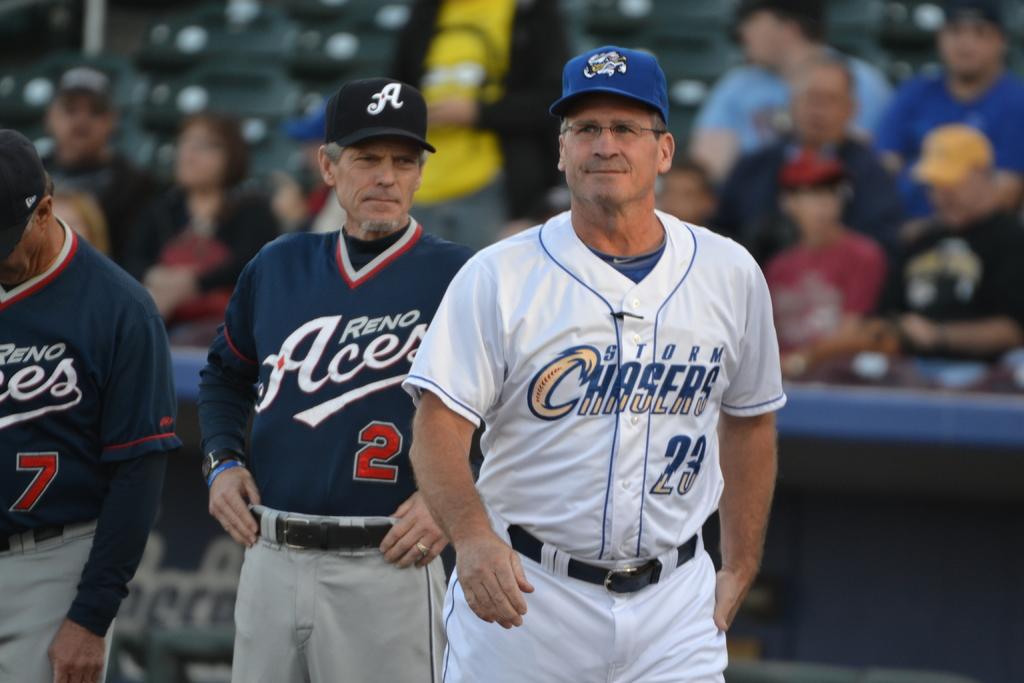What number of the team is the man in the white?
Provide a succinct answer. 23. What is the blue teams name?
Offer a terse response. Aces. 